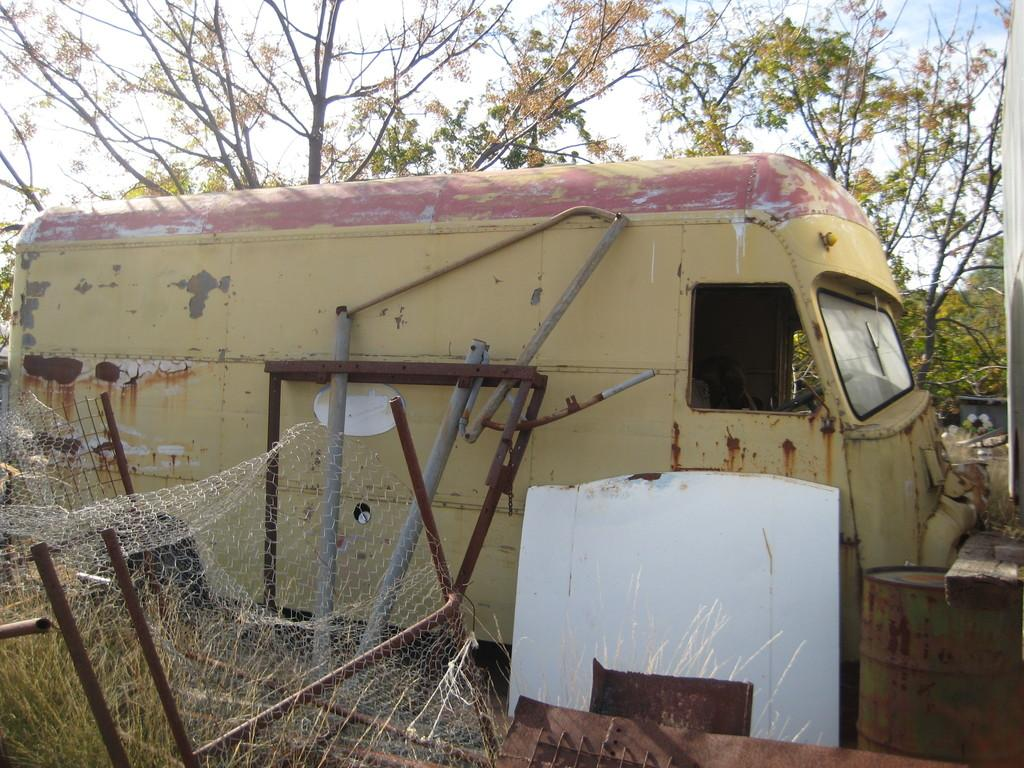What type of vegetation can be seen in the image? There are trees in the image. What type of transportation is visible in the image? There are vehicles in the image. What type of structure can be seen in the image? There are poles in the image. What type of barrier is present in the image? There is net fencing in the image. What type of ground cover is visible in the image? There is grass in the image. What type of musical instrument is present in the image? There is a drum in the image. What part of the natural environment is visible in the image? The sky is visible in the image. What other objects can be seen in the image? There are other objects in the image, but their specific details are not mentioned in the provided facts. What type of sleet can be seen falling from the trees in the image? There is no mention of sleet in the image, and the presence of trees does not necessarily imply that sleet is falling from them. 